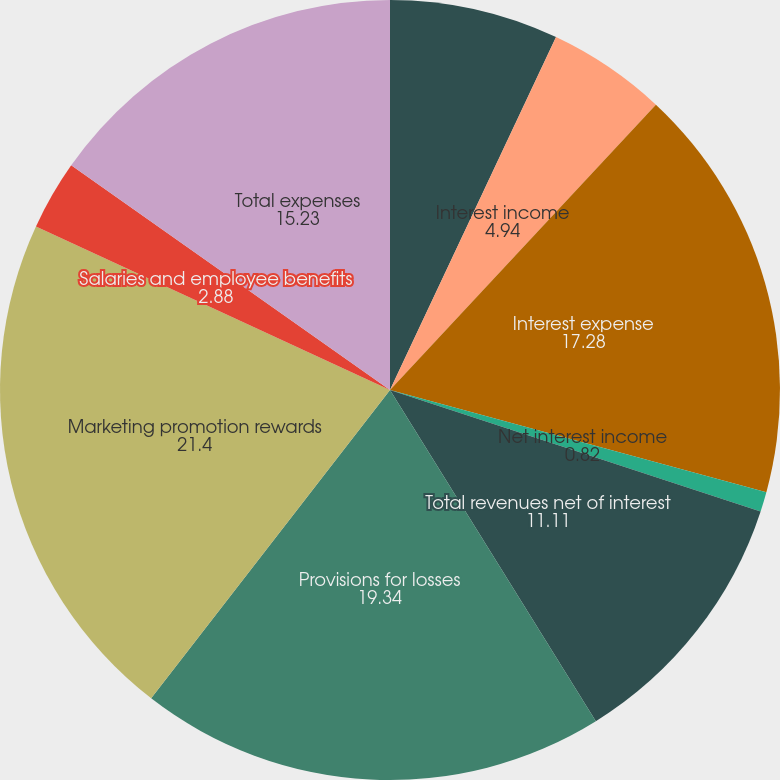Convert chart to OTSL. <chart><loc_0><loc_0><loc_500><loc_500><pie_chart><fcel>Non-interest revenues<fcel>Interest income<fcel>Interest expense<fcel>Net interest income<fcel>Total revenues net of interest<fcel>Provisions for losses<fcel>Marketing promotion rewards<fcel>Salaries and employee benefits<fcel>Total expenses<nl><fcel>7.0%<fcel>4.94%<fcel>17.28%<fcel>0.82%<fcel>11.11%<fcel>19.34%<fcel>21.4%<fcel>2.88%<fcel>15.23%<nl></chart> 